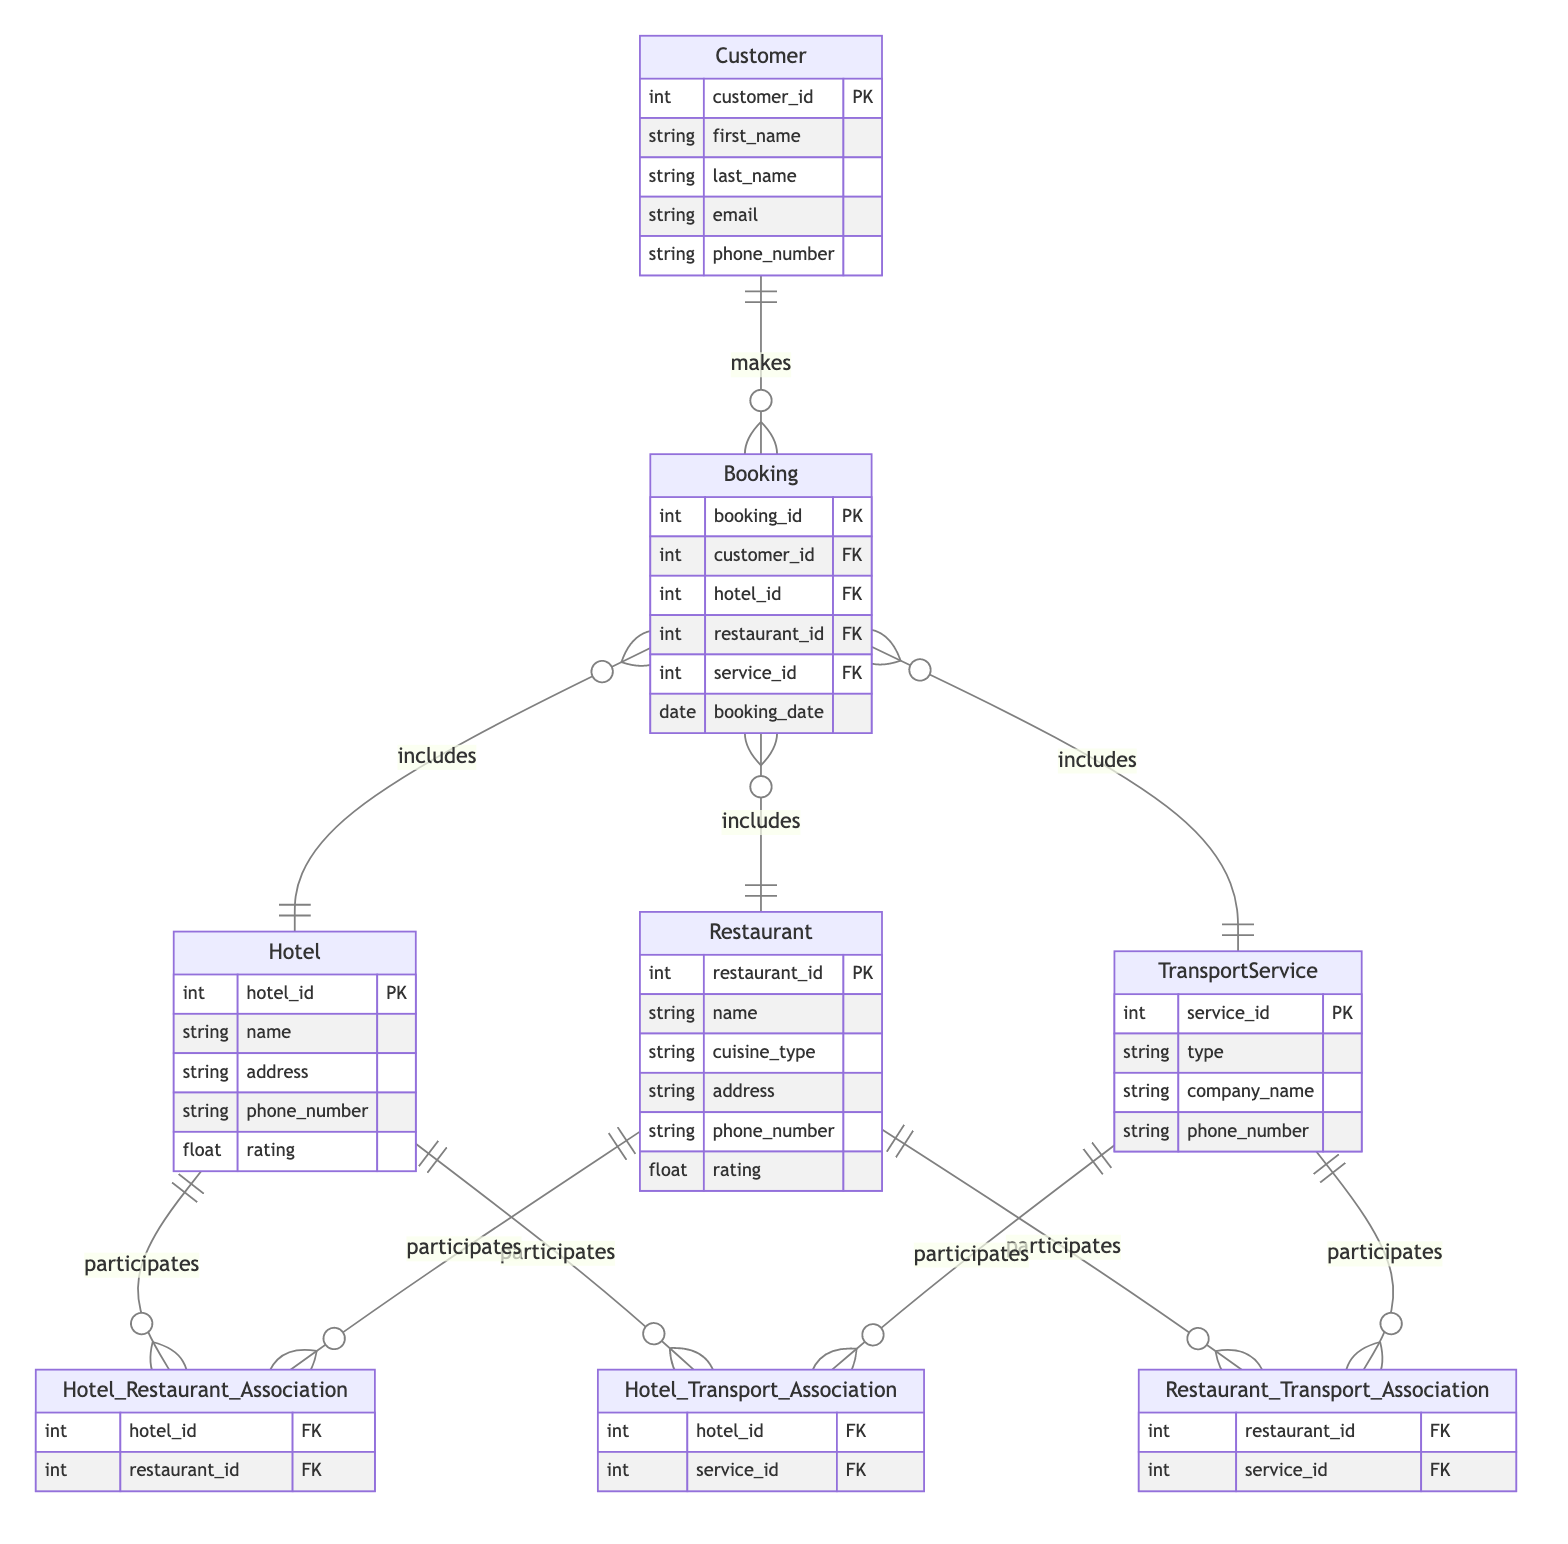What are the attributes of the Hotel entity? The Hotel entity has the attributes hotel_id, name, address, phone_number, and rating, which are explicitly listed in the diagram under the Hotel section.
Answer: hotel_id, name, address, phone_number, rating How many relationships are depicted in this diagram? The diagram shows four main relationships: Hotel_Restaurant_Association, Hotel_Transport_Association, Restaurant_Transport_Association, and Customer_Booking, so a total of four relationships can be counted.
Answer: 4 What is the type of relationship between Hotel and Restaurant? The relationship between Hotel and Restaurant is specified as many_to_many in the diagram, indicating that one hotel can associate with multiple restaurants and vice versa.
Answer: many_to_many Which entity can make a Booking? The Customer entity is the one that makes a Booking, as indicated by the Customer_Booking relationship, illustrating that one customer can create multiple bookings.
Answer: Customer How many attributes does the Restaurant entity have? The Restaurant entity has six attributes listed: restaurant_id, name, cuisine_type, address, phone_number, and rating, which can be counted directly from the diagram.
Answer: 6 Which entities are involved in the Hotel_Transport_Association? The Hotel_Transport_Association involves the Hotel and TransportService entities, as indicated by the connecting line and the labels in the diagram.
Answer: Hotel, TransportService How many entities are connected through the Restaurant_Transport_Association? The Restaurant_Transport_Association connects two entities: Restaurant and TransportService, which can be inferred from the relationship depicted in the diagram.
Answer: 2 Can a Booking include multiple hotels? No, based on the diagram, each Booking can only include one Hotel at a time, as indicated by the notation showing a one-to-many relationship between Customer and Booking.
Answer: No What is the primary key for the Customer entity? The primary key for the Customer entity is customer_id, which is marked as PK in the diagram, clearly indicating it as the unique identifier for customers.
Answer: customer_id 